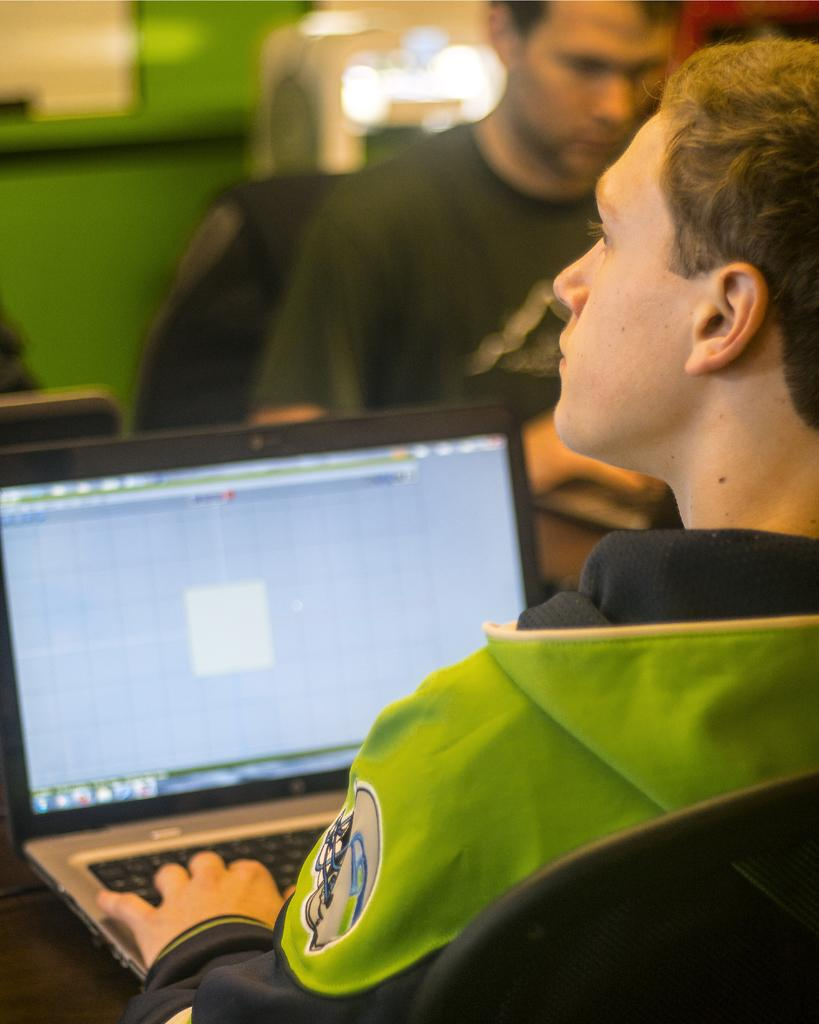Who or what is present in the image? There are people in the image. What electronic device can be seen in the image? There is a laptop on a platform in the image. What can be seen in the distance behind the people and laptop? There are objects in the background of the image. How would you describe the appearance of the background? The background is blurry. What type of quartz can be seen in the image? There is no quartz present in the image. What is the chance of winning a prize in the image? There is no indication of a prize or chance in the image. 